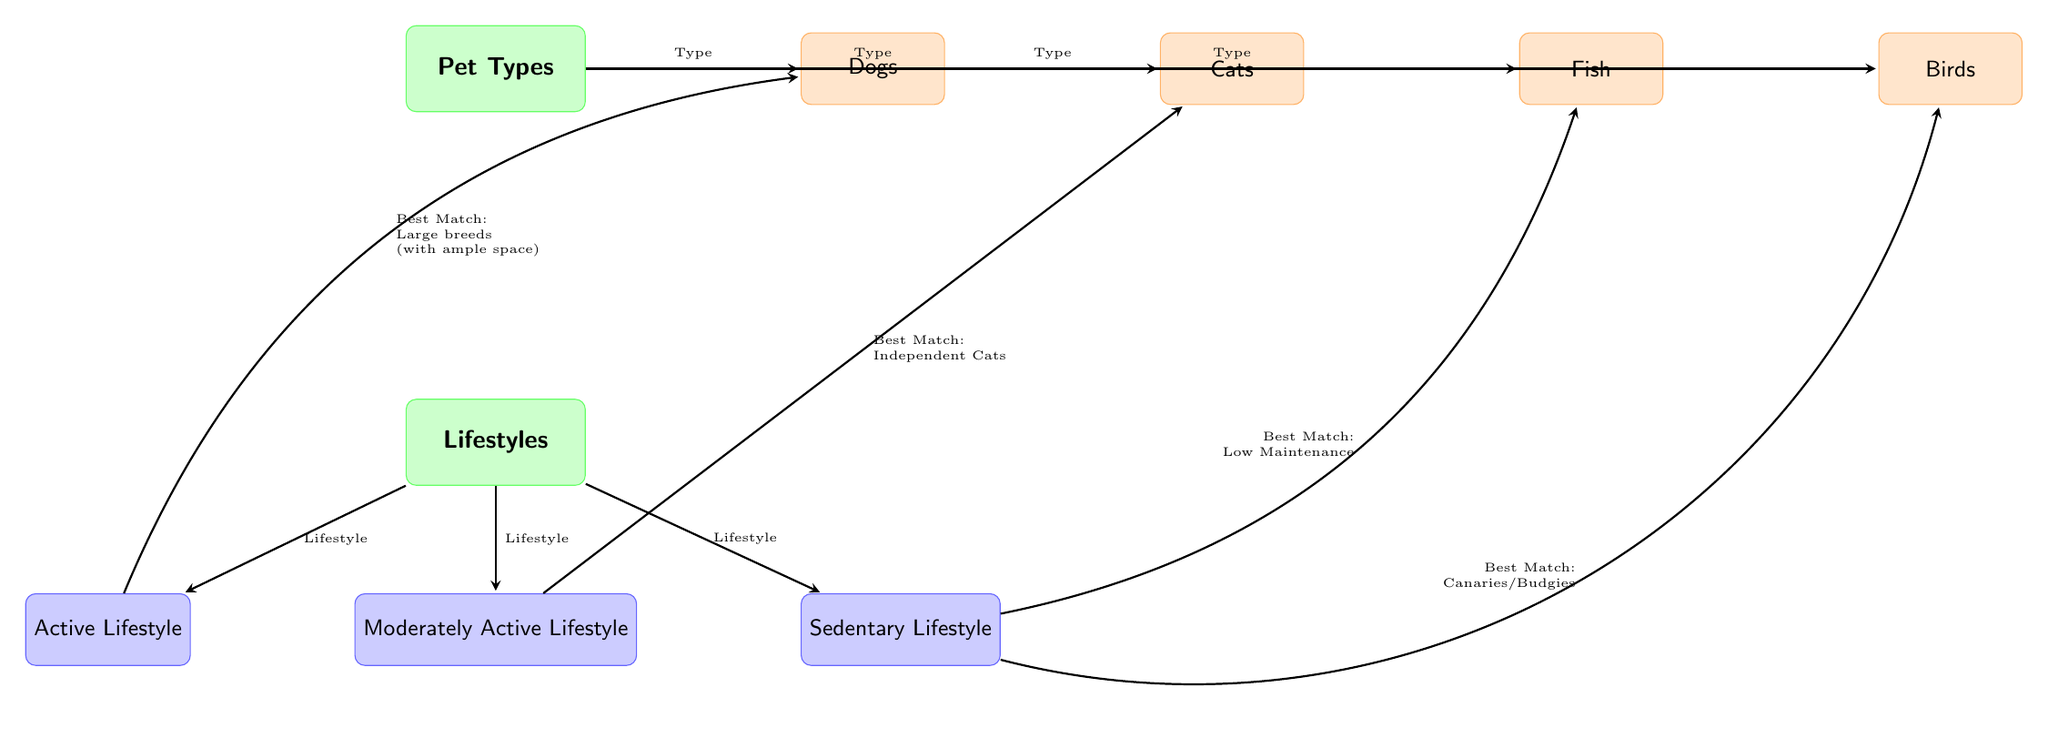What types of pets are illustrated in the diagram? The diagram shows four pet types: Dogs, Cats, Fish, and Birds, which are all labeled in the main section.
Answer: Dogs, Cats, Fish, Birds Which pet type is best matched with an active lifestyle? The active lifestyle node connects to the dogs node, indicating that dogs are the best match for those with an active lifestyle.
Answer: Dogs How many different lifestyles are represented in the diagram? There are three lifestyle nodes: Active Lifestyle, Moderately Active Lifestyle, and Sedentary Lifestyle. Thus, the total count of lifestyle nodes is three.
Answer: 3 What type of pet is associated with a sedentary lifestyle? The sedentary lifestyle node is connected to both Fish and Birds, which indicates that these pets are suitable for a sedentary lifestyle.
Answer: Fish, Birds Which pet is suggested for someone with a moderately active lifestyle? The moderately active lifestyle node is linked to the cats node, which signifies that cats are the best match for someone with a moderately active lifestyle.
Answer: Cats Are large breeds mentioned as suitable pets for an active lifestyle? Yes, the diagram indicates that large breeds are best matched with those who have an active lifestyle. This information is conveyed through the connection between the active lifestyle node and dogs, with a specific note about large breeds.
Answer: Yes What is the best match for a sedentary lifestyle in terms of pet care? The diagram details two options: low maintenance pets like fish and smaller birds like canaries or budgies for someone with a sedentary lifestyle.
Answer: Fish, Canaries/Budgies Which type of pets requires minimal maintenance according to the diagram? The diagram indicates that fish are low maintenance pets, making them suitable for individuals seeking less demanding pet care.
Answer: Fish 